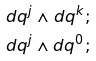<formula> <loc_0><loc_0><loc_500><loc_500>d q ^ { j } \wedge d q ^ { k } ; \\ d q ^ { j } \wedge d q ^ { 0 } ;</formula> 